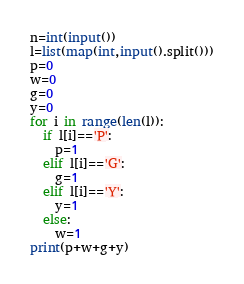Convert code to text. <code><loc_0><loc_0><loc_500><loc_500><_Python_>n=int(input())
l=list(map(int,input().split()))
p=0
w=0
g=0
y=0
for i in range(len(l)):
  if l[i]=='P':
    p=1
  elif l[i]=='G':
    g=1
  elif l[i]=='Y':
    y=1
  else:
    w=1 
print(p+w+g+y)</code> 